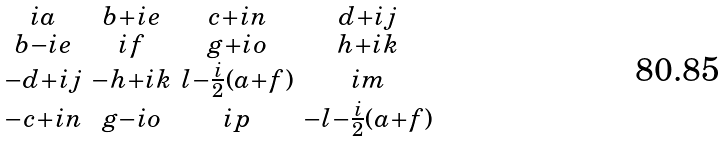<formula> <loc_0><loc_0><loc_500><loc_500>\begin{smallmatrix} i a & b + i e & c + i n & d + i j \\ b - i e & i f & g + i o & h + i k \\ - d + i j & - h + i k & l - \frac { i } { 2 } ( a + f ) & i m \\ - c + i n & g - i o & i p & - l - \frac { i } { 2 } ( a + f ) \end{smallmatrix}</formula> 